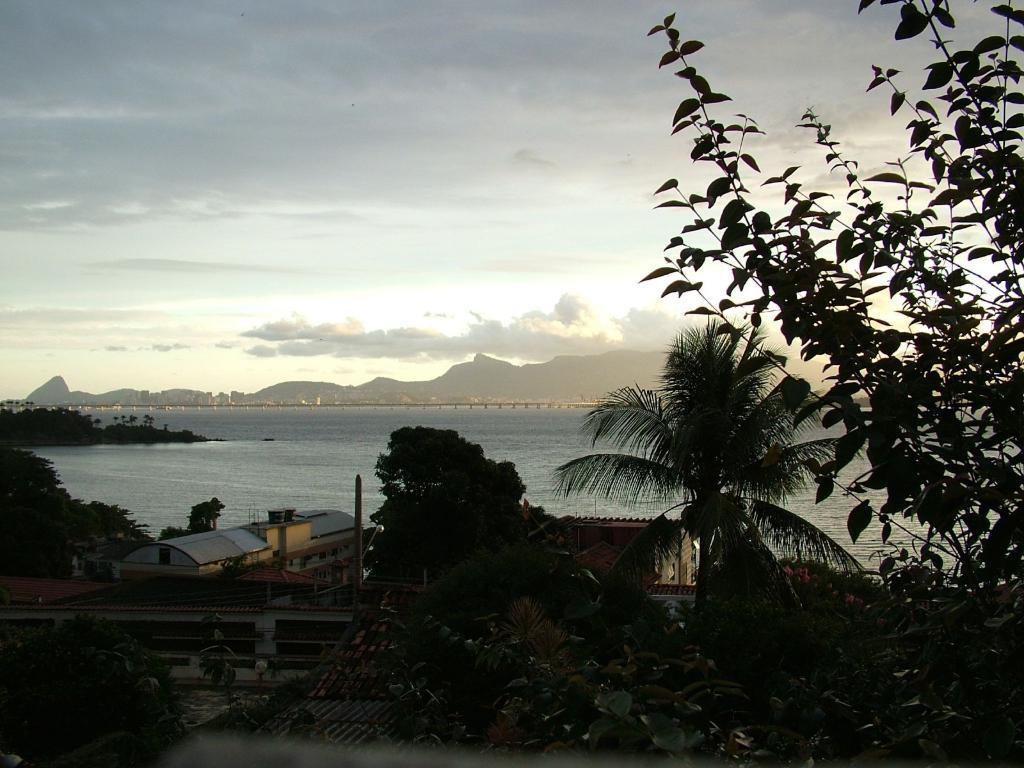In one or two sentences, can you explain what this image depicts? In this image we can see there are some buildings and trees. In the background there is a river, mountains and sky. 